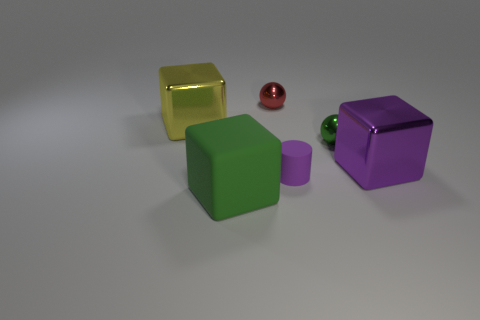There is a large metal cube to the left of the purple metallic thing; how many large green blocks are right of it?
Keep it short and to the point. 1. Are there any yellow metal objects to the right of the big purple shiny thing?
Offer a terse response. No. There is a green object on the left side of the tiny red sphere; does it have the same shape as the small purple thing?
Offer a terse response. No. There is a tiny thing that is the same color as the large matte cube; what is its material?
Offer a terse response. Metal. What number of large rubber cubes are the same color as the tiny matte cylinder?
Your answer should be compact. 0. The rubber thing that is to the right of the shiny sphere that is to the left of the purple cylinder is what shape?
Your answer should be compact. Cylinder. Is there a small green thing that has the same shape as the big rubber object?
Your answer should be compact. No. Do the large rubber object and the large metallic block left of the large green block have the same color?
Provide a short and direct response. No. There is a block that is the same color as the small matte cylinder; what size is it?
Your answer should be compact. Large. Is there a yellow thing that has the same size as the matte cube?
Offer a very short reply. Yes. 